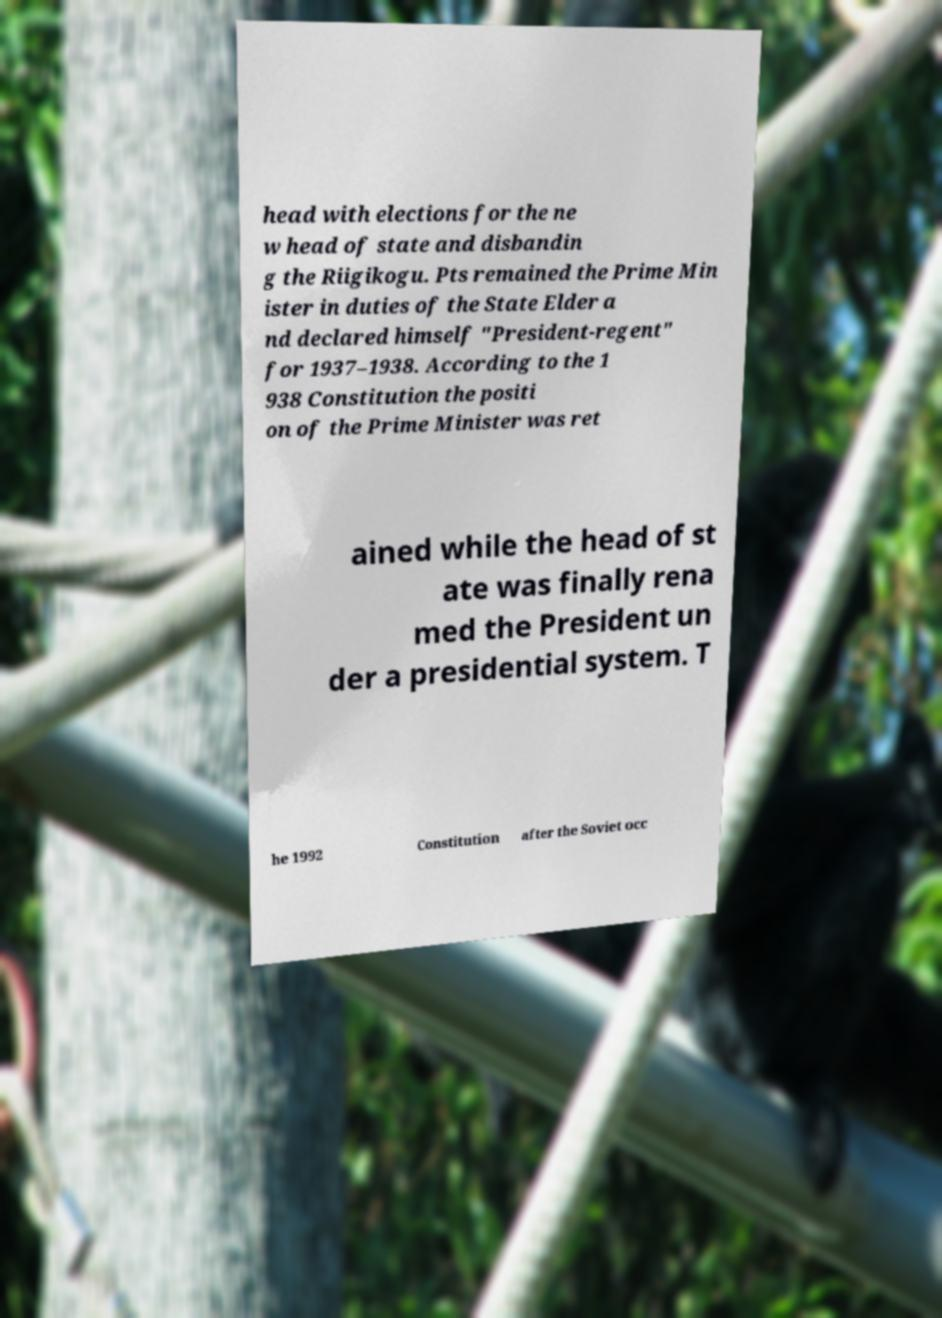I need the written content from this picture converted into text. Can you do that? head with elections for the ne w head of state and disbandin g the Riigikogu. Pts remained the Prime Min ister in duties of the State Elder a nd declared himself "President-regent" for 1937–1938. According to the 1 938 Constitution the positi on of the Prime Minister was ret ained while the head of st ate was finally rena med the President un der a presidential system. T he 1992 Constitution after the Soviet occ 